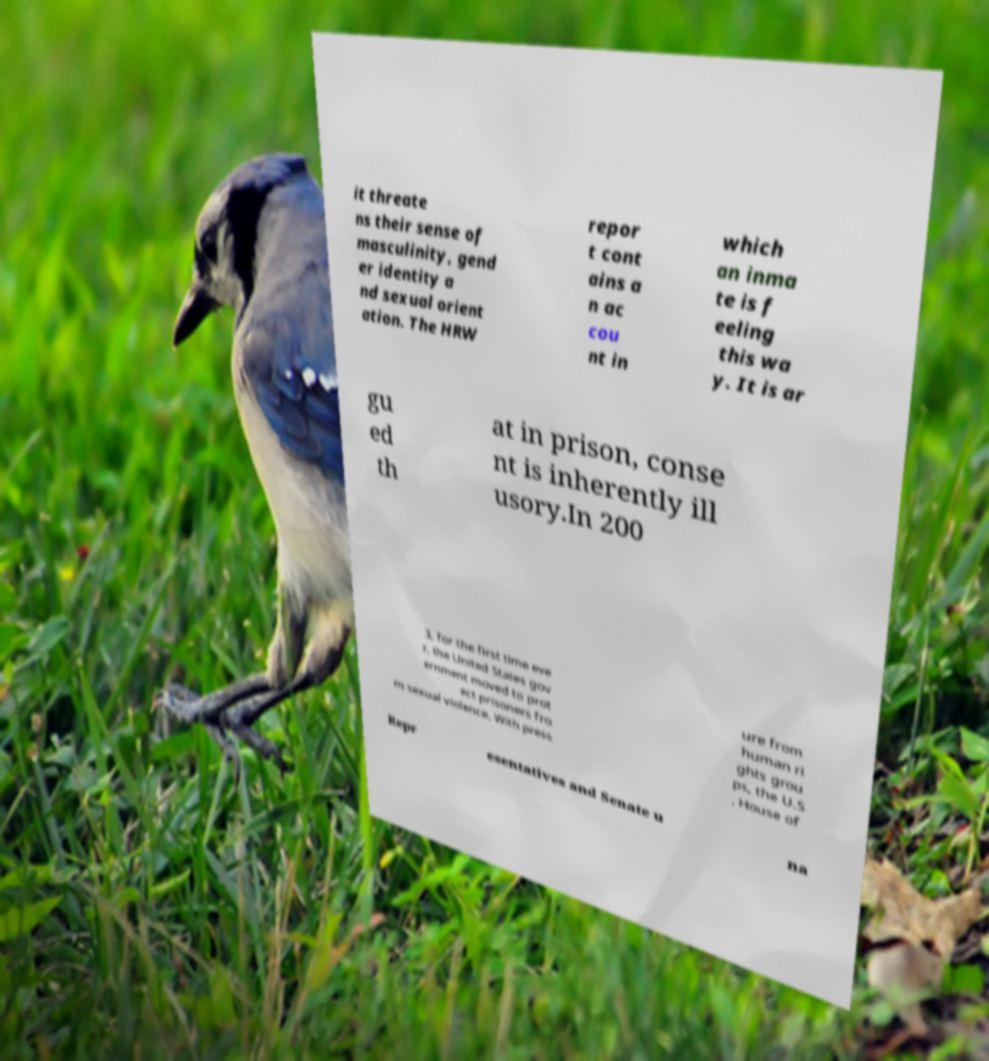Can you read and provide the text displayed in the image?This photo seems to have some interesting text. Can you extract and type it out for me? it threate ns their sense of masculinity, gend er identity a nd sexual orient ation. The HRW repor t cont ains a n ac cou nt in which an inma te is f eeling this wa y. It is ar gu ed th at in prison, conse nt is inherently ill usory.In 200 3, for the first time eve r, the United States gov ernment moved to prot ect prisoners fro m sexual violence. With press ure from human ri ghts grou ps, the U.S . House of Repr esentatives and Senate u na 